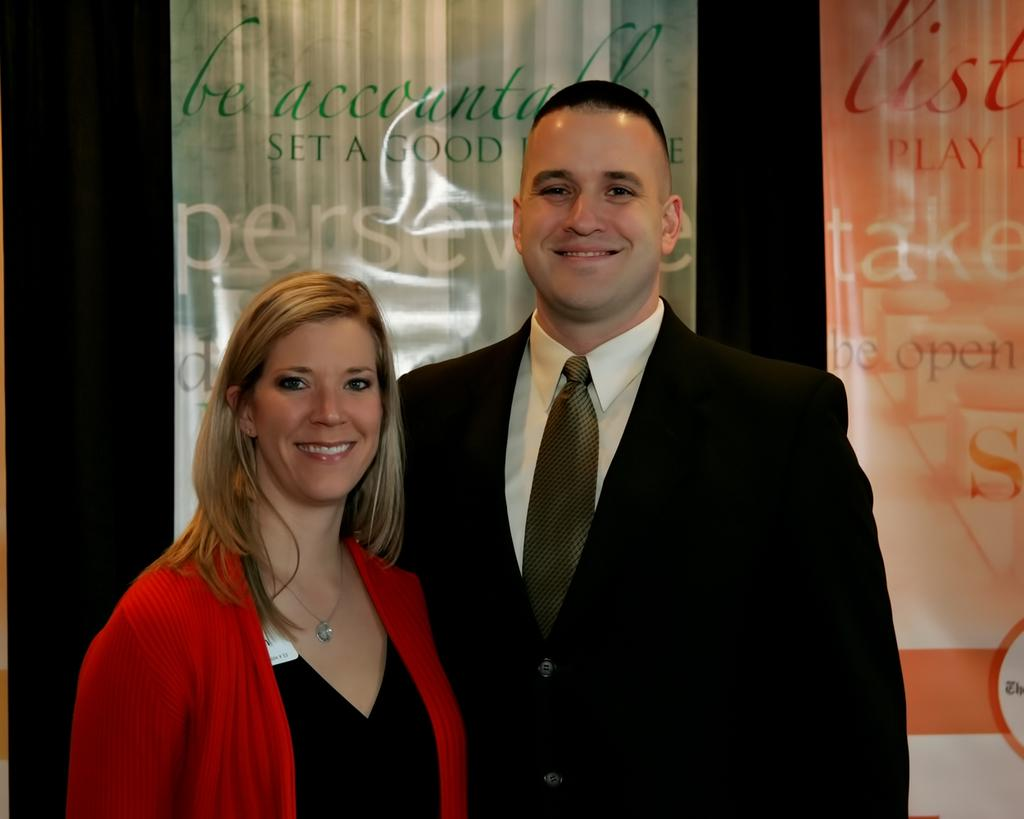How many people are present in the image? There are two people standing in the image. Can you describe the background of the image? There is a board or banner with text in the background of the image. What type of ink is used to write the text on the vase in the image? There is no vase present in the image, and therefore no ink or text on a vase can be observed. 